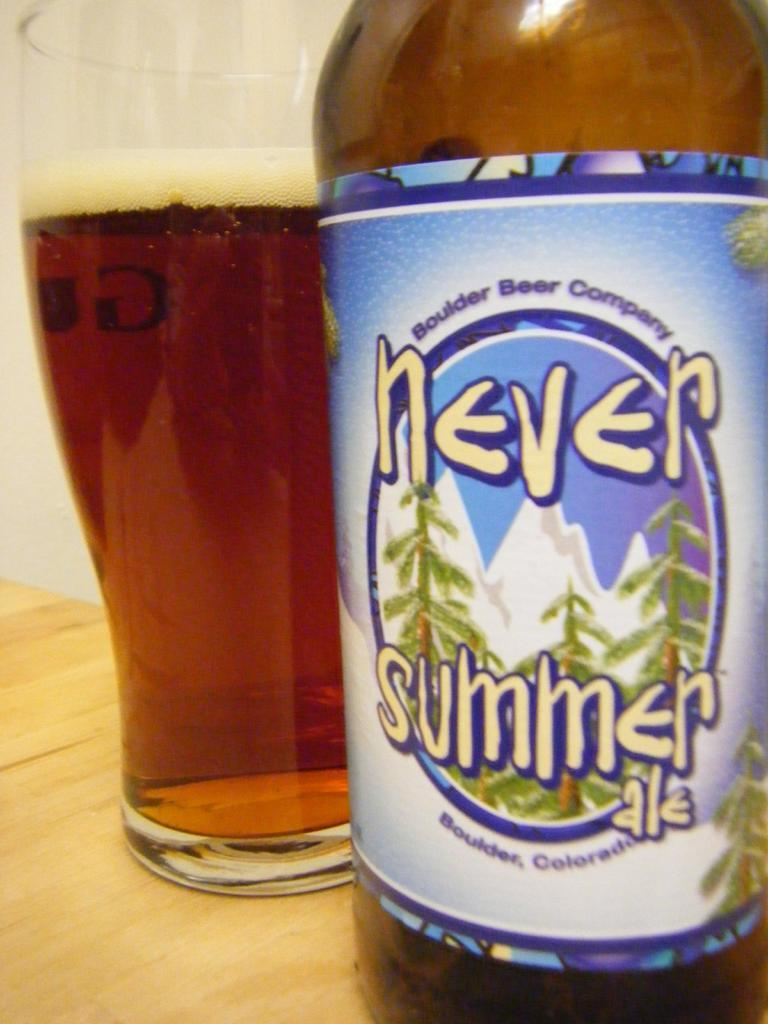<image>
Give a short and clear explanation of the subsequent image. Bottle of Never Summer beer trees and mountains on the label. 